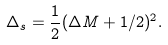Convert formula to latex. <formula><loc_0><loc_0><loc_500><loc_500>\Delta _ { s } = { \frac { 1 } { 2 } } ( \Delta M + 1 / 2 ) ^ { 2 } .</formula> 